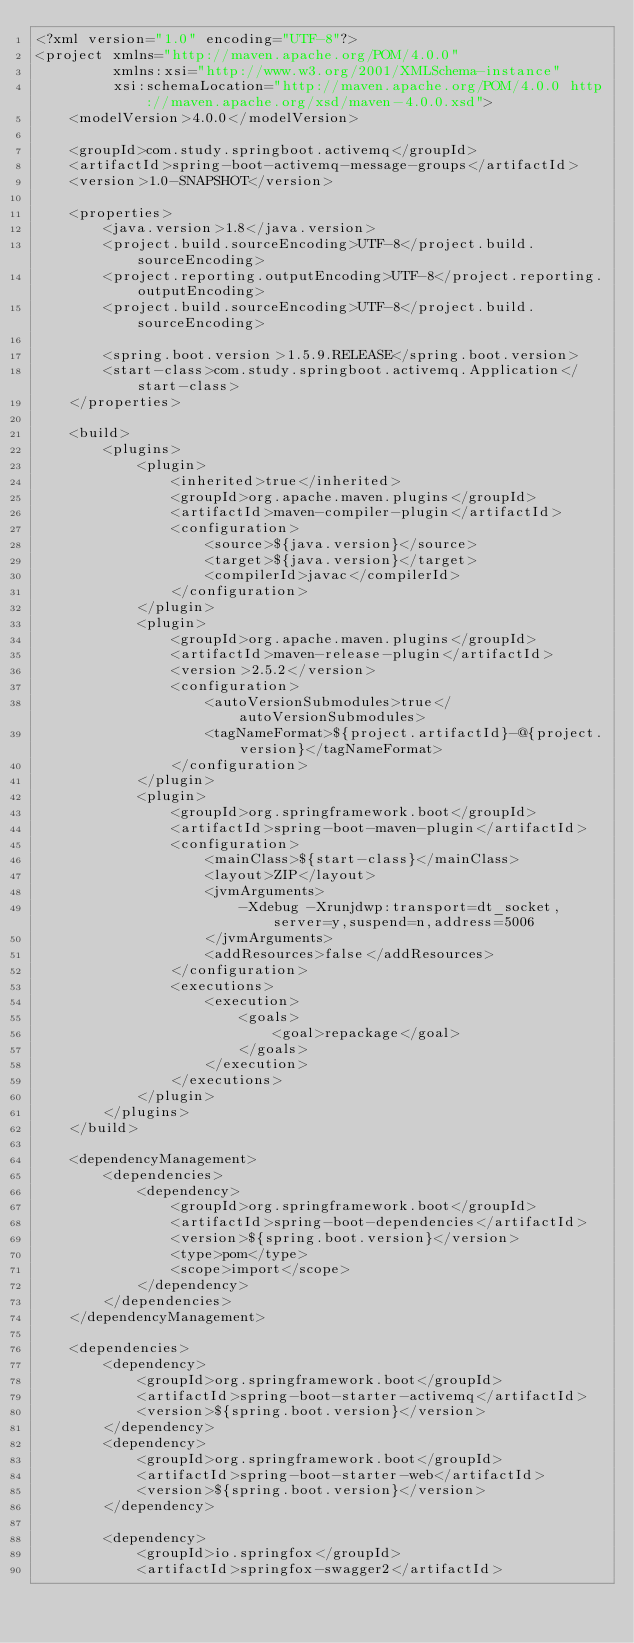Convert code to text. <code><loc_0><loc_0><loc_500><loc_500><_XML_><?xml version="1.0" encoding="UTF-8"?>
<project xmlns="http://maven.apache.org/POM/4.0.0"
         xmlns:xsi="http://www.w3.org/2001/XMLSchema-instance"
         xsi:schemaLocation="http://maven.apache.org/POM/4.0.0 http://maven.apache.org/xsd/maven-4.0.0.xsd">
    <modelVersion>4.0.0</modelVersion>

    <groupId>com.study.springboot.activemq</groupId>
    <artifactId>spring-boot-activemq-message-groups</artifactId>
    <version>1.0-SNAPSHOT</version>

    <properties>
        <java.version>1.8</java.version>
        <project.build.sourceEncoding>UTF-8</project.build.sourceEncoding>
        <project.reporting.outputEncoding>UTF-8</project.reporting.outputEncoding>
        <project.build.sourceEncoding>UTF-8</project.build.sourceEncoding>

        <spring.boot.version>1.5.9.RELEASE</spring.boot.version>
        <start-class>com.study.springboot.activemq.Application</start-class>
    </properties>

    <build>
        <plugins>
            <plugin>
                <inherited>true</inherited>
                <groupId>org.apache.maven.plugins</groupId>
                <artifactId>maven-compiler-plugin</artifactId>
                <configuration>
                    <source>${java.version}</source>
                    <target>${java.version}</target>
                    <compilerId>javac</compilerId>
                </configuration>
            </plugin>
            <plugin>
                <groupId>org.apache.maven.plugins</groupId>
                <artifactId>maven-release-plugin</artifactId>
                <version>2.5.2</version>
                <configuration>
                    <autoVersionSubmodules>true</autoVersionSubmodules>
                    <tagNameFormat>${project.artifactId}-@{project.version}</tagNameFormat>
                </configuration>
            </plugin>
            <plugin>
                <groupId>org.springframework.boot</groupId>
                <artifactId>spring-boot-maven-plugin</artifactId>
                <configuration>
                    <mainClass>${start-class}</mainClass>
                    <layout>ZIP</layout>
                    <jvmArguments>
                        -Xdebug -Xrunjdwp:transport=dt_socket,server=y,suspend=n,address=5006
                    </jvmArguments>
                    <addResources>false</addResources>
                </configuration>
                <executions>
                    <execution>
                        <goals>
                            <goal>repackage</goal>
                        </goals>
                    </execution>
                </executions>
            </plugin>
        </plugins>
    </build>

    <dependencyManagement>
        <dependencies>
            <dependency>
                <groupId>org.springframework.boot</groupId>
                <artifactId>spring-boot-dependencies</artifactId>
                <version>${spring.boot.version}</version>
                <type>pom</type>
                <scope>import</scope>
            </dependency>
        </dependencies>
    </dependencyManagement>

    <dependencies>
        <dependency>
            <groupId>org.springframework.boot</groupId>
            <artifactId>spring-boot-starter-activemq</artifactId>
            <version>${spring.boot.version}</version>
        </dependency>
        <dependency>
            <groupId>org.springframework.boot</groupId>
            <artifactId>spring-boot-starter-web</artifactId>
            <version>${spring.boot.version}</version>
        </dependency>

        <dependency>
            <groupId>io.springfox</groupId>
            <artifactId>springfox-swagger2</artifactId></code> 